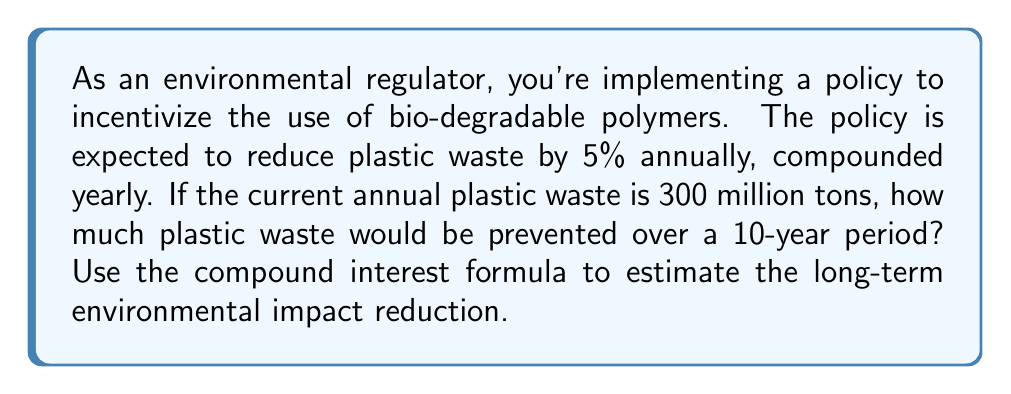Solve this math problem. To solve this problem, we'll use the compound interest formula and calculate the difference between the initial amount and the reduced amount after 10 years.

1. The compound interest formula is:
   $A = P(1 + r)^t$
   Where:
   $A$ = Final amount
   $P$ = Principal (initial amount)
   $r$ = Annual rate (as a decimal)
   $t$ = Time in years

2. In this case:
   $P = 300$ million tons
   $r = -0.05$ (5% reduction, so it's negative)
   $t = 10$ years

3. Calculate the amount of plastic waste after 10 years:
   $A = 300(1 - 0.05)^{10}$
   $A = 300(0.95)^{10}$
   $A = 300 \cdot 0.5987369392$
   $A \approx 179.62$ million tons

4. Calculate the amount of plastic waste prevented:
   Waste prevented = Initial amount - Amount after 10 years
   Waste prevented = $300 - 179.62 = 120.38$ million tons

Therefore, the policy would prevent approximately 120.38 million tons of plastic waste over a 10-year period.
Answer: Approximately 120.38 million tons of plastic waste would be prevented over a 10-year period. 